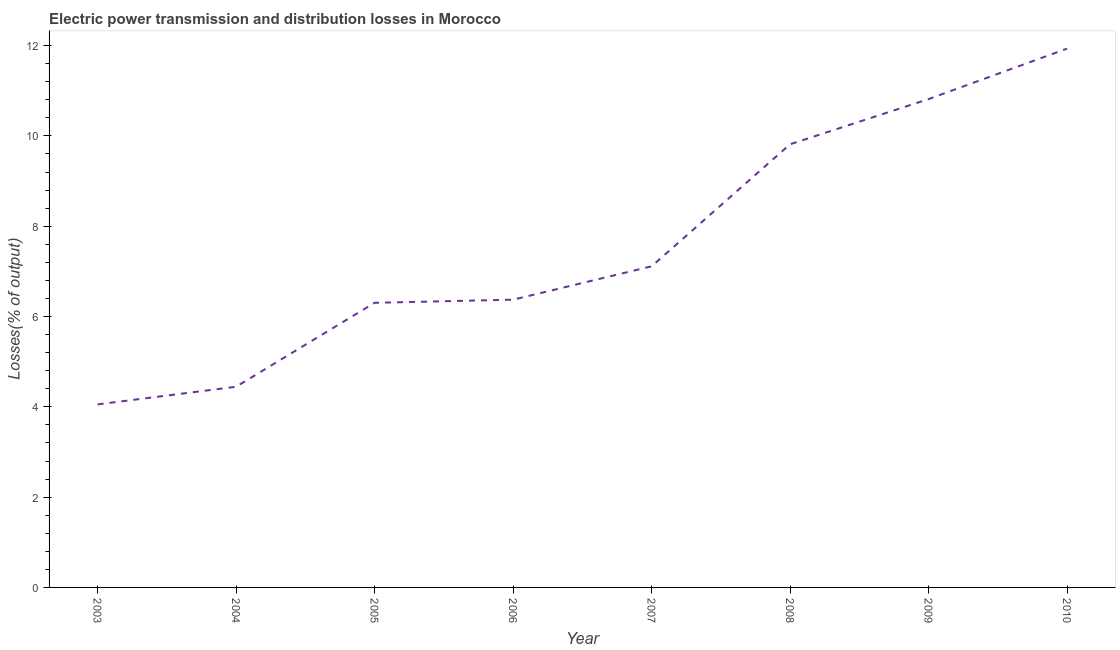What is the electric power transmission and distribution losses in 2004?
Give a very brief answer. 4.45. Across all years, what is the maximum electric power transmission and distribution losses?
Make the answer very short. 11.93. Across all years, what is the minimum electric power transmission and distribution losses?
Offer a terse response. 4.05. In which year was the electric power transmission and distribution losses maximum?
Offer a very short reply. 2010. What is the sum of the electric power transmission and distribution losses?
Ensure brevity in your answer.  60.85. What is the difference between the electric power transmission and distribution losses in 2005 and 2006?
Ensure brevity in your answer.  -0.07. What is the average electric power transmission and distribution losses per year?
Provide a succinct answer. 7.61. What is the median electric power transmission and distribution losses?
Give a very brief answer. 6.74. What is the ratio of the electric power transmission and distribution losses in 2003 to that in 2005?
Your answer should be compact. 0.64. What is the difference between the highest and the second highest electric power transmission and distribution losses?
Give a very brief answer. 1.12. What is the difference between the highest and the lowest electric power transmission and distribution losses?
Keep it short and to the point. 7.88. What is the difference between two consecutive major ticks on the Y-axis?
Keep it short and to the point. 2. Are the values on the major ticks of Y-axis written in scientific E-notation?
Make the answer very short. No. Does the graph contain grids?
Provide a succinct answer. No. What is the title of the graph?
Your answer should be compact. Electric power transmission and distribution losses in Morocco. What is the label or title of the X-axis?
Your answer should be compact. Year. What is the label or title of the Y-axis?
Make the answer very short. Losses(% of output). What is the Losses(% of output) of 2003?
Provide a succinct answer. 4.05. What is the Losses(% of output) in 2004?
Your answer should be very brief. 4.45. What is the Losses(% of output) of 2005?
Offer a very short reply. 6.3. What is the Losses(% of output) in 2006?
Provide a succinct answer. 6.37. What is the Losses(% of output) of 2007?
Offer a terse response. 7.11. What is the Losses(% of output) of 2008?
Your answer should be compact. 9.82. What is the Losses(% of output) in 2009?
Provide a succinct answer. 10.82. What is the Losses(% of output) of 2010?
Provide a short and direct response. 11.93. What is the difference between the Losses(% of output) in 2003 and 2004?
Your answer should be very brief. -0.39. What is the difference between the Losses(% of output) in 2003 and 2005?
Your answer should be very brief. -2.25. What is the difference between the Losses(% of output) in 2003 and 2006?
Your answer should be compact. -2.32. What is the difference between the Losses(% of output) in 2003 and 2007?
Your answer should be very brief. -3.06. What is the difference between the Losses(% of output) in 2003 and 2008?
Your answer should be compact. -5.76. What is the difference between the Losses(% of output) in 2003 and 2009?
Provide a short and direct response. -6.76. What is the difference between the Losses(% of output) in 2003 and 2010?
Your answer should be very brief. -7.88. What is the difference between the Losses(% of output) in 2004 and 2005?
Give a very brief answer. -1.86. What is the difference between the Losses(% of output) in 2004 and 2006?
Your answer should be compact. -1.93. What is the difference between the Losses(% of output) in 2004 and 2007?
Your answer should be very brief. -2.67. What is the difference between the Losses(% of output) in 2004 and 2008?
Offer a terse response. -5.37. What is the difference between the Losses(% of output) in 2004 and 2009?
Your answer should be very brief. -6.37. What is the difference between the Losses(% of output) in 2004 and 2010?
Your response must be concise. -7.49. What is the difference between the Losses(% of output) in 2005 and 2006?
Offer a terse response. -0.07. What is the difference between the Losses(% of output) in 2005 and 2007?
Give a very brief answer. -0.81. What is the difference between the Losses(% of output) in 2005 and 2008?
Offer a terse response. -3.51. What is the difference between the Losses(% of output) in 2005 and 2009?
Keep it short and to the point. -4.51. What is the difference between the Losses(% of output) in 2005 and 2010?
Provide a succinct answer. -5.63. What is the difference between the Losses(% of output) in 2006 and 2007?
Provide a short and direct response. -0.74. What is the difference between the Losses(% of output) in 2006 and 2008?
Provide a succinct answer. -3.44. What is the difference between the Losses(% of output) in 2006 and 2009?
Your response must be concise. -4.44. What is the difference between the Losses(% of output) in 2006 and 2010?
Keep it short and to the point. -5.56. What is the difference between the Losses(% of output) in 2007 and 2008?
Offer a very short reply. -2.7. What is the difference between the Losses(% of output) in 2007 and 2009?
Your answer should be very brief. -3.7. What is the difference between the Losses(% of output) in 2007 and 2010?
Keep it short and to the point. -4.82. What is the difference between the Losses(% of output) in 2008 and 2009?
Provide a short and direct response. -1. What is the difference between the Losses(% of output) in 2008 and 2010?
Provide a succinct answer. -2.12. What is the difference between the Losses(% of output) in 2009 and 2010?
Provide a short and direct response. -1.12. What is the ratio of the Losses(% of output) in 2003 to that in 2004?
Your answer should be compact. 0.91. What is the ratio of the Losses(% of output) in 2003 to that in 2005?
Your response must be concise. 0.64. What is the ratio of the Losses(% of output) in 2003 to that in 2006?
Make the answer very short. 0.64. What is the ratio of the Losses(% of output) in 2003 to that in 2007?
Keep it short and to the point. 0.57. What is the ratio of the Losses(% of output) in 2003 to that in 2008?
Offer a terse response. 0.41. What is the ratio of the Losses(% of output) in 2003 to that in 2009?
Ensure brevity in your answer.  0.38. What is the ratio of the Losses(% of output) in 2003 to that in 2010?
Give a very brief answer. 0.34. What is the ratio of the Losses(% of output) in 2004 to that in 2005?
Provide a short and direct response. 0.7. What is the ratio of the Losses(% of output) in 2004 to that in 2006?
Ensure brevity in your answer.  0.7. What is the ratio of the Losses(% of output) in 2004 to that in 2007?
Provide a succinct answer. 0.62. What is the ratio of the Losses(% of output) in 2004 to that in 2008?
Your response must be concise. 0.45. What is the ratio of the Losses(% of output) in 2004 to that in 2009?
Ensure brevity in your answer.  0.41. What is the ratio of the Losses(% of output) in 2004 to that in 2010?
Provide a short and direct response. 0.37. What is the ratio of the Losses(% of output) in 2005 to that in 2007?
Make the answer very short. 0.89. What is the ratio of the Losses(% of output) in 2005 to that in 2008?
Offer a terse response. 0.64. What is the ratio of the Losses(% of output) in 2005 to that in 2009?
Keep it short and to the point. 0.58. What is the ratio of the Losses(% of output) in 2005 to that in 2010?
Your answer should be very brief. 0.53. What is the ratio of the Losses(% of output) in 2006 to that in 2007?
Give a very brief answer. 0.9. What is the ratio of the Losses(% of output) in 2006 to that in 2008?
Provide a short and direct response. 0.65. What is the ratio of the Losses(% of output) in 2006 to that in 2009?
Keep it short and to the point. 0.59. What is the ratio of the Losses(% of output) in 2006 to that in 2010?
Give a very brief answer. 0.53. What is the ratio of the Losses(% of output) in 2007 to that in 2008?
Offer a terse response. 0.72. What is the ratio of the Losses(% of output) in 2007 to that in 2009?
Offer a terse response. 0.66. What is the ratio of the Losses(% of output) in 2007 to that in 2010?
Your response must be concise. 0.6. What is the ratio of the Losses(% of output) in 2008 to that in 2009?
Your answer should be compact. 0.91. What is the ratio of the Losses(% of output) in 2008 to that in 2010?
Offer a very short reply. 0.82. What is the ratio of the Losses(% of output) in 2009 to that in 2010?
Give a very brief answer. 0.91. 